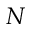<formula> <loc_0><loc_0><loc_500><loc_500>N</formula> 